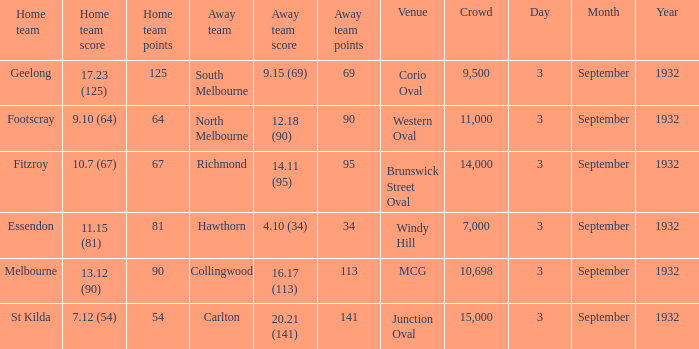What is the total Crowd number for the team that has an Away team score of 12.18 (90)? 11000.0. 